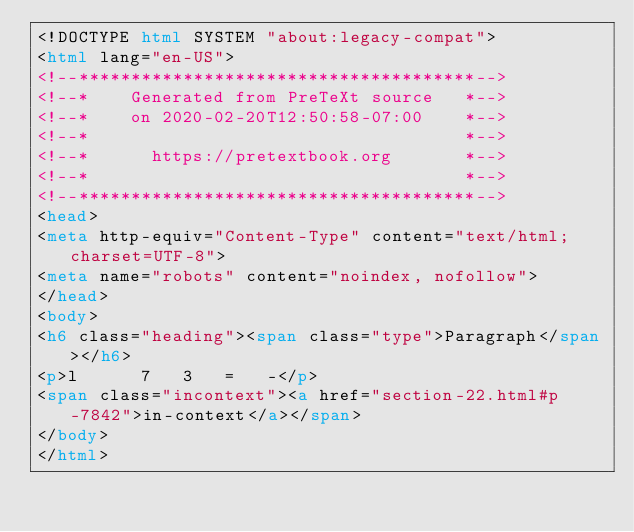<code> <loc_0><loc_0><loc_500><loc_500><_HTML_><!DOCTYPE html SYSTEM "about:legacy-compat">
<html lang="en-US">
<!--**************************************-->
<!--*    Generated from PreTeXt source   *-->
<!--*    on 2020-02-20T12:50:58-07:00    *-->
<!--*                                    *-->
<!--*      https://pretextbook.org       *-->
<!--*                                    *-->
<!--**************************************-->
<head>
<meta http-equiv="Content-Type" content="text/html; charset=UTF-8">
<meta name="robots" content="noindex, nofollow">
</head>
<body>
<h6 class="heading"><span class="type">Paragraph</span></h6>
<p>l      7   3   =   -</p>
<span class="incontext"><a href="section-22.html#p-7842">in-context</a></span>
</body>
</html>
</code> 